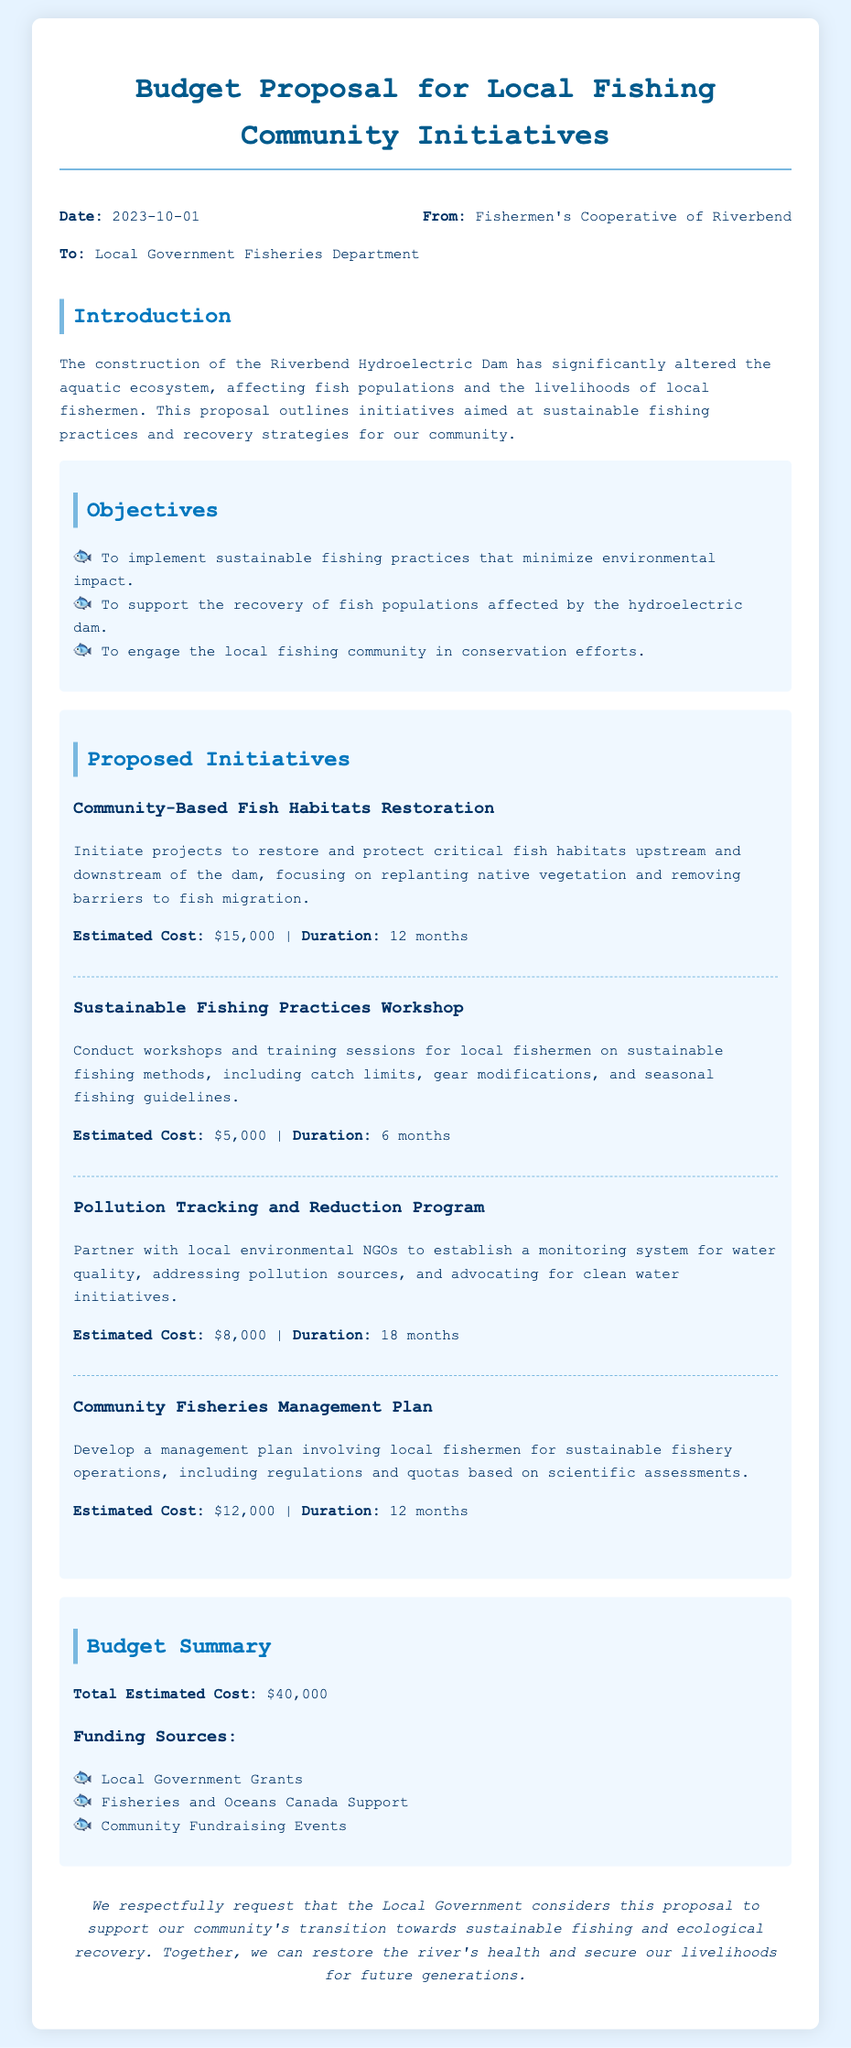what is the date of the memo? The date of the memo is stated at the beginning of the document, which is 2023-10-01.
Answer: 2023-10-01 who is the memo addressed to? The memo is addressed to the Local Government Fisheries Department, as indicated in the memo header.
Answer: Local Government Fisheries Department what is the total estimated cost of the budget proposal? The total estimated cost is provided in the budget summary section of the memo, which is $40,000.
Answer: $40,000 how much will the Community-Based Fish Habitats Restoration initiative cost? The estimated cost for the Community-Based Fish Habitats Restoration initiative is mentioned in the proposed initiatives section.
Answer: $15,000 what is one objective mentioned in the document? An objective is outlined in the objectives section of the memo, stating the aim to implement sustainable fishing practices.
Answer: To implement sustainable fishing practices what is the duration of the Sustainable Fishing Practices Workshop? The duration of the Sustainable Fishing Practices Workshop is specified in the initiatives section, which is 6 months.
Answer: 6 months what initiative focuses on addressing pollution sources? The initiative that focuses on pollution sources is identified in the proposed initiatives section as the Pollution Tracking and Reduction Program.
Answer: Pollution Tracking and Reduction Program why is the proposal being made? The proposal is made to support the community's transition towards sustainable fishing and ecological recovery following the impacts of the dam.
Answer: To support sustainable fishing and ecological recovery how many proposed initiatives are mentioned in the document? The number of proposed initiatives can be counted in the initiatives section of the memo, which lists four initiatives.
Answer: Four initiatives 